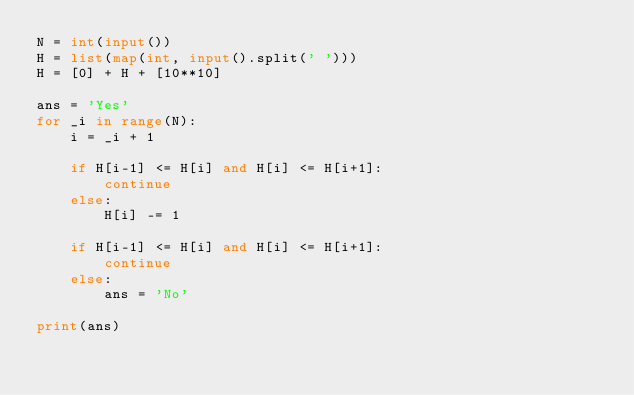<code> <loc_0><loc_0><loc_500><loc_500><_Python_>N = int(input())
H = list(map(int, input().split(' ')))
H = [0] + H + [10**10]

ans = 'Yes'
for _i in range(N):
    i = _i + 1

    if H[i-1] <= H[i] and H[i] <= H[i+1]:
        continue
    else:
        H[i] -= 1

    if H[i-1] <= H[i] and H[i] <= H[i+1]:
        continue
    else:
        ans = 'No'

print(ans)</code> 